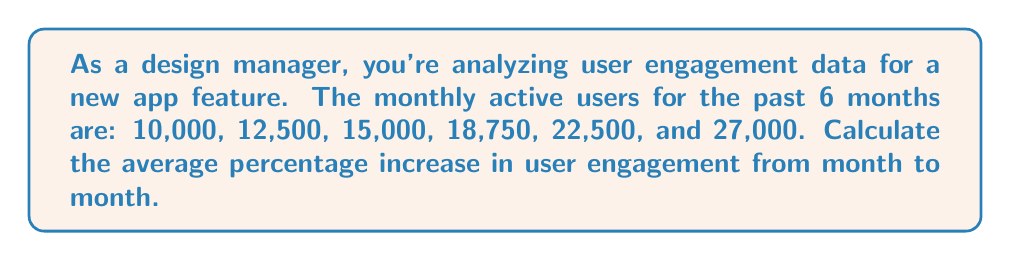Teach me how to tackle this problem. To solve this problem, we'll follow these steps:

1. Calculate the percentage increase for each month:

   Month 1 to 2: $\frac{12500 - 10000}{10000} \times 100 = 25\%$
   Month 2 to 3: $\frac{15000 - 12500}{12500} \times 100 = 20\%$
   Month 3 to 4: $\frac{18750 - 15000}{15000} \times 100 = 25\%$
   Month 4 to 5: $\frac{22500 - 18750}{18750} \times 100 = 20\%$
   Month 5 to 6: $\frac{27000 - 22500}{22500} \times 100 = 20\%$

2. Sum up all the percentage increases:
   $25\% + 20\% + 25\% + 20\% + 20\% = 110\%$

3. Calculate the average by dividing the sum by the number of intervals (5):
   $\frac{110\%}{5} = 22\%$

Therefore, the average percentage increase in user engagement from month to month is 22%.
Answer: 22% 